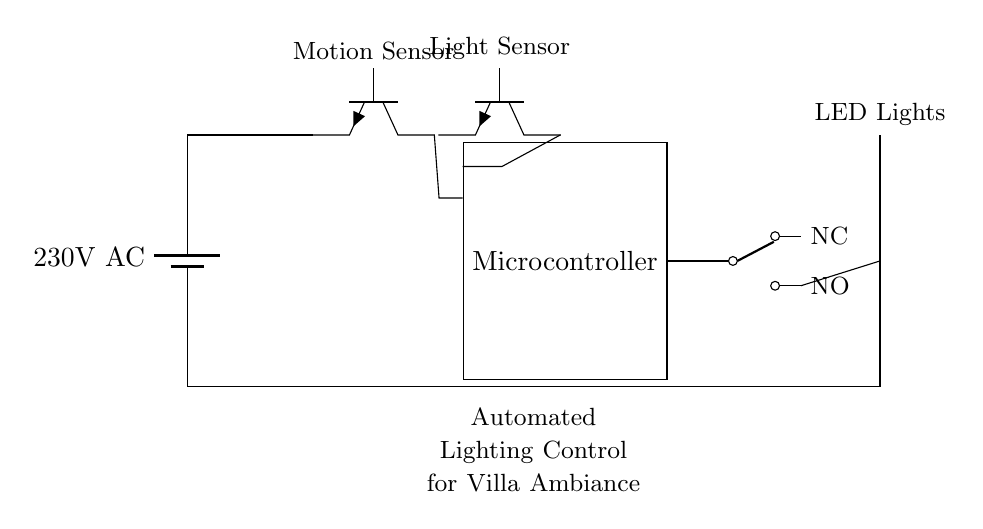What is the power supply voltage for this circuit? The circuit diagram indicates that the power supply is a battery labeled with a voltage of 230 volts AC, which is the standard voltage for many electrical systems.
Answer: 230 volts AC What is the role of the microcontroller in this circuit? The microcontroller serves as the control unit that processes signals from the motion and light sensors to manage the operation of the relay, which in turn controls the LED lights. It is responsible for automating the lighting based on sensor inputs.
Answer: Control unit How many LED lights are shown in this circuit? The diagram features one LED light depicted at the end of the circuit, which is controlled by the relay. This is evident as it's labeled directly on the circuit.
Answer: One What is connected to the NC terminal of the relay? The diagram does not explicitly show any connection to the NC (Normally Closed) terminal of the relay, indicating that it may not be utilized in this specific configuration.
Answer: No connection What triggers the activation of the LED lights in this circuit? The activation of the LED lights is triggered by the signals received from the motion sensor and light sensor, which are monitored by the microcontroller. When appropriate conditions are met, the microcontroller activates the relay, powering the lights.
Answer: Motion and light sensors What component receives input from both the motion and light sensors? The microcontroller is the component that receives input from both the motion sensor and the light sensor, as shown by their connections leading to it in the circuit diagram. This indicates its role in processing sensor data for lighting control.
Answer: Microcontroller 